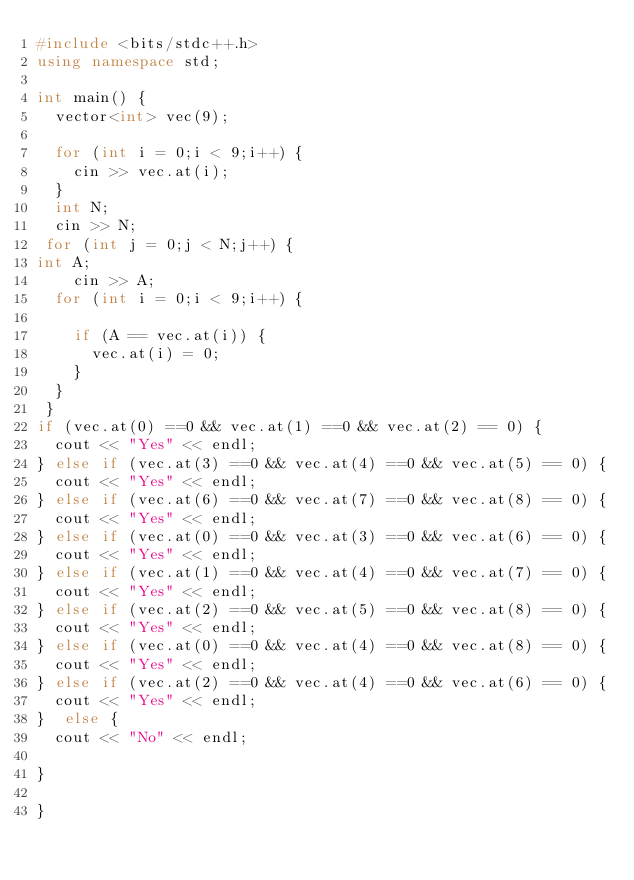Convert code to text. <code><loc_0><loc_0><loc_500><loc_500><_C++_>#include <bits/stdc++.h>
using namespace std;
 
int main() {
  vector<int> vec(9);

  for (int i = 0;i < 9;i++) {
    cin >> vec.at(i);
  }
  int N;
  cin >> N;
 for (int j = 0;j < N;j++) {
int A;
    cin >> A;
  for (int i = 0;i < 9;i++) {
    
    if (A == vec.at(i)) {
      vec.at(i) = 0;
    }
  }
 }
if (vec.at(0) ==0 && vec.at(1) ==0 && vec.at(2) == 0) {
  cout << "Yes" << endl;
} else if (vec.at(3) ==0 && vec.at(4) ==0 && vec.at(5) == 0) {
  cout << "Yes" << endl;
} else if (vec.at(6) ==0 && vec.at(7) ==0 && vec.at(8) == 0) {
  cout << "Yes" << endl;
} else if (vec.at(0) ==0 && vec.at(3) ==0 && vec.at(6) == 0) {
  cout << "Yes" << endl;
} else if (vec.at(1) ==0 && vec.at(4) ==0 && vec.at(7) == 0) {
  cout << "Yes" << endl;
} else if (vec.at(2) ==0 && vec.at(5) ==0 && vec.at(8) == 0) {
  cout << "Yes" << endl;
} else if (vec.at(0) ==0 && vec.at(4) ==0 && vec.at(8) == 0) {
  cout << "Yes" << endl;
} else if (vec.at(2) ==0 && vec.at(4) ==0 && vec.at(6) == 0) {
  cout << "Yes" << endl;
}  else {
  cout << "No" << endl;

}

}

</code> 